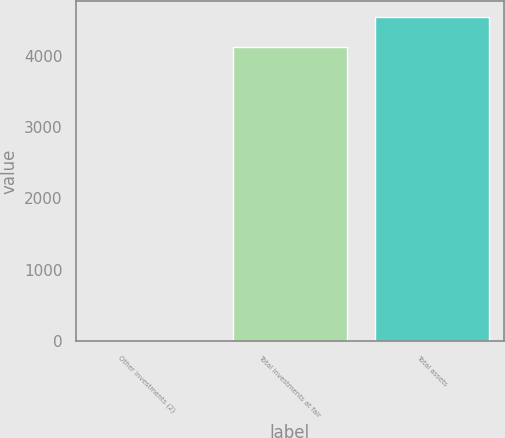Convert chart. <chart><loc_0><loc_0><loc_500><loc_500><bar_chart><fcel>Other investments (2)<fcel>Total investments at fair<fcel>Total assets<nl><fcel>4<fcel>4131<fcel>4543.7<nl></chart> 